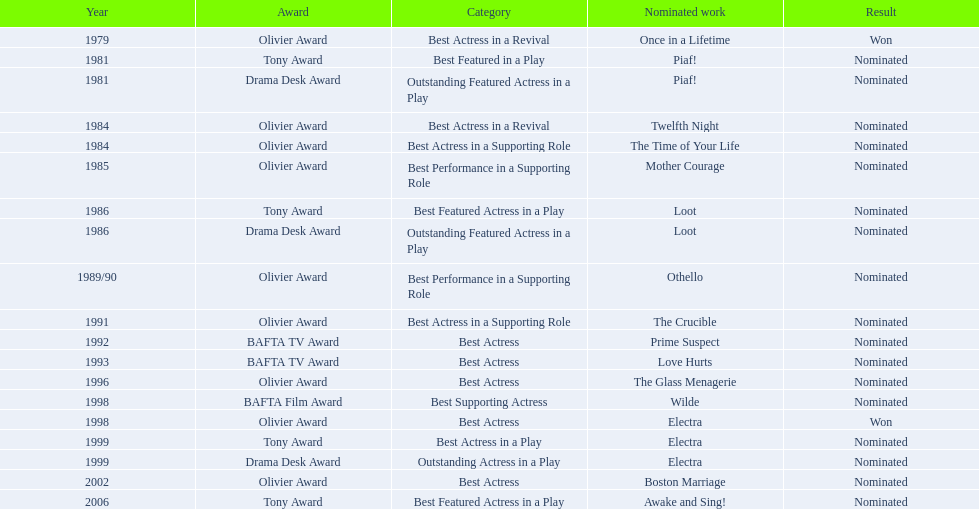What were all of the nominated works with zoe wanamaker? Once in a Lifetime, Piaf!, Piaf!, Twelfth Night, The Time of Your Life, Mother Courage, Loot, Loot, Othello, The Crucible, Prime Suspect, Love Hurts, The Glass Menagerie, Wilde, Electra, Electra, Electra, Boston Marriage, Awake and Sing!. And in which years were these nominations? 1979, 1981, 1981, 1984, 1984, 1985, 1986, 1986, 1989/90, 1991, 1992, 1993, 1996, 1998, 1998, 1999, 1999, 2002, 2006. Which categories was she nominated for in 1984? Best Actress in a Revival. And for which work was this nomination? Twelfth Night. 